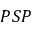Convert formula to latex. <formula><loc_0><loc_0><loc_500><loc_500>P S P</formula> 